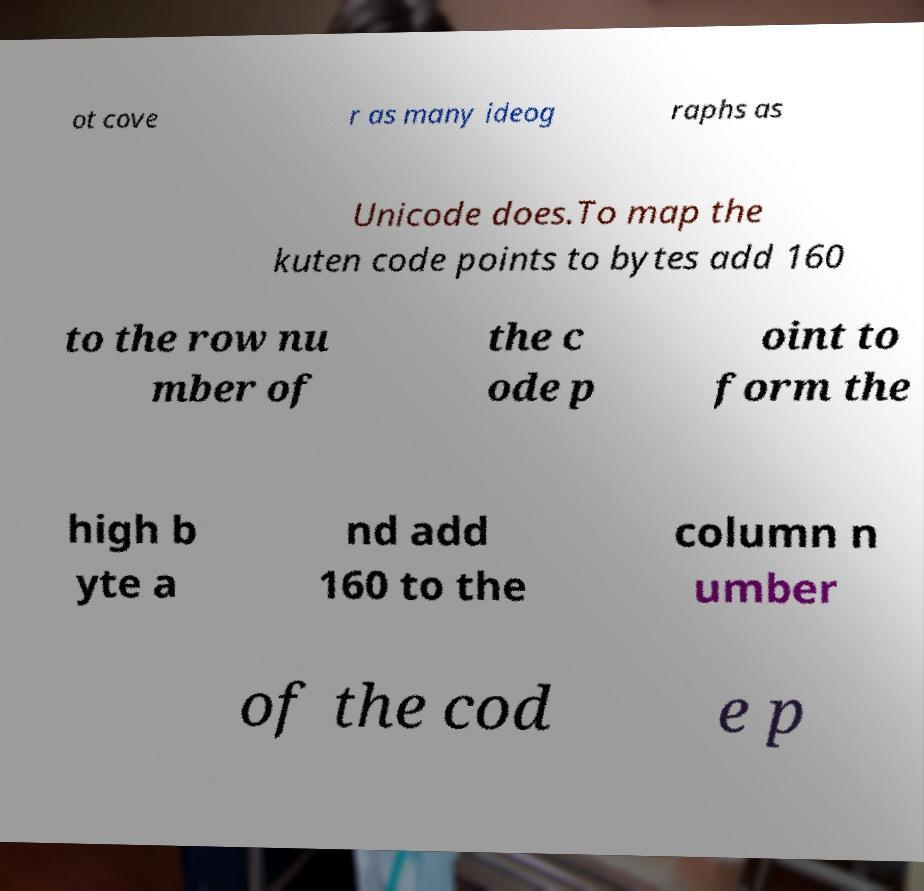There's text embedded in this image that I need extracted. Can you transcribe it verbatim? ot cove r as many ideog raphs as Unicode does.To map the kuten code points to bytes add 160 to the row nu mber of the c ode p oint to form the high b yte a nd add 160 to the column n umber of the cod e p 